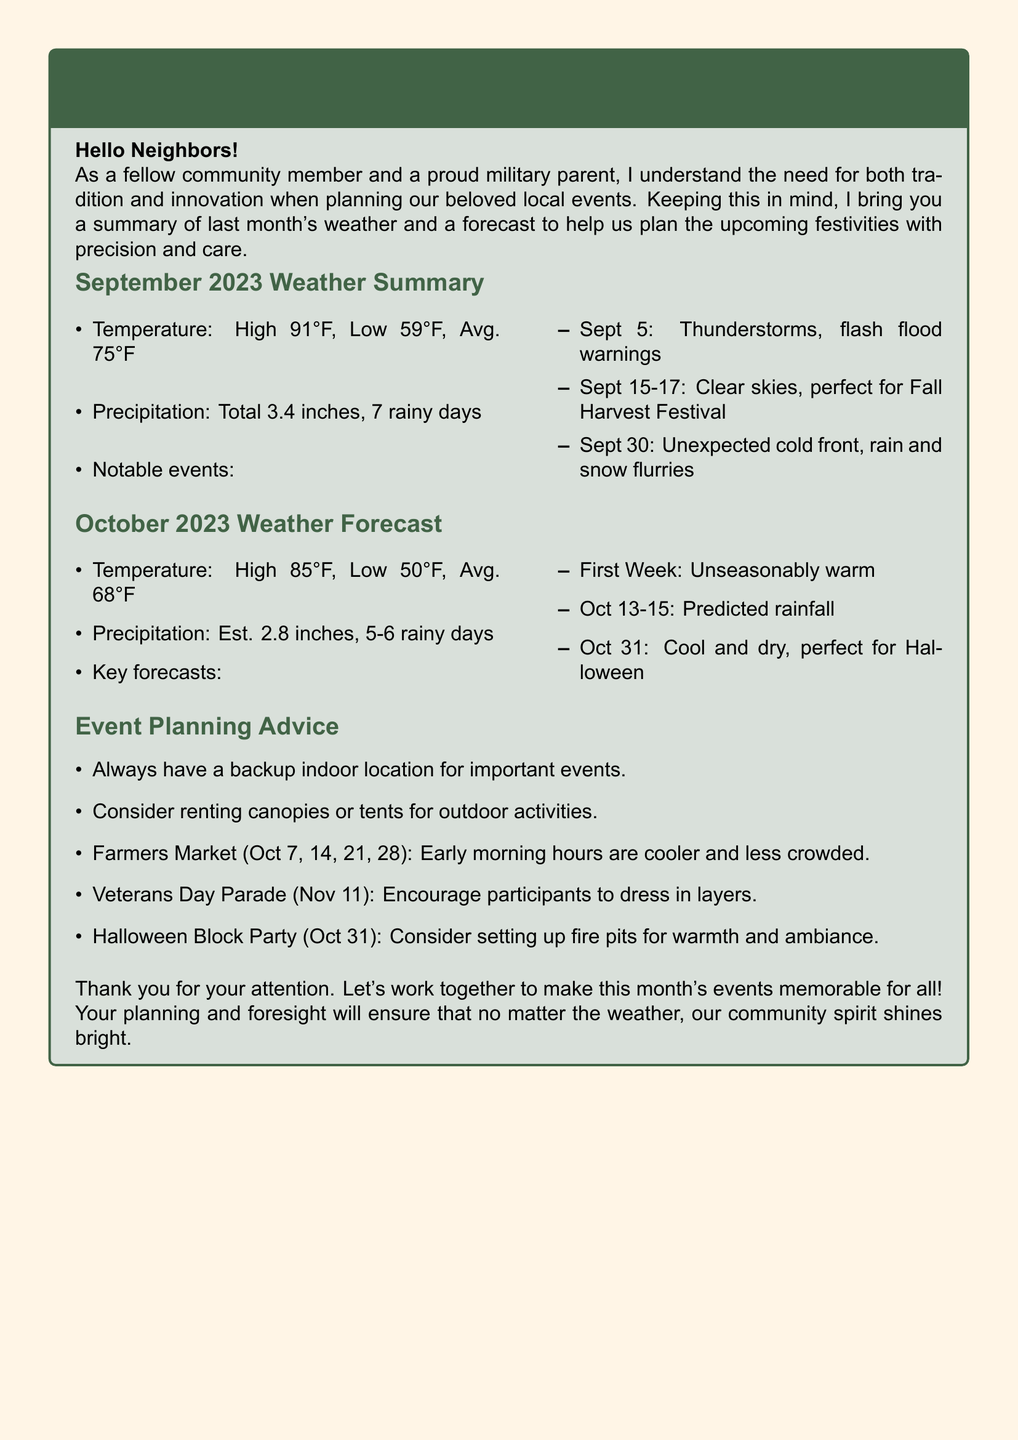What was the highest temperature in September 2023? The highest temperature recorded in September 2023 was 91°F.
Answer: 91°F How many rainy days were there in September 2023? There were a total of 7 rainy days in September 2023.
Answer: 7 What is the estimated precipitation for October 2023? The estimated precipitation for October 2023 is 2.8 inches.
Answer: 2.8 inches Which event had clear skies from September 15-17? The clear skies from September 15-17 were perfect for the Fall Harvest Festival.
Answer: Fall Harvest Festival What planning advice is given for the Veterans Day Parade? The advice for the Veterans Day Parade is to encourage participants to dress in layers.
Answer: Dress in layers When is the Halloween Block Party scheduled? The Halloween Block Party is scheduled for October 31.
Answer: October 31 What is notable about the weather on October 31? October 31 is predicted to be cool and dry, which is perfect for Halloween.
Answer: Cool and dry How many days of rainfall are anticipated in October? The forecast anticipates 5-6 rainy days in October.
Answer: 5-6 days 